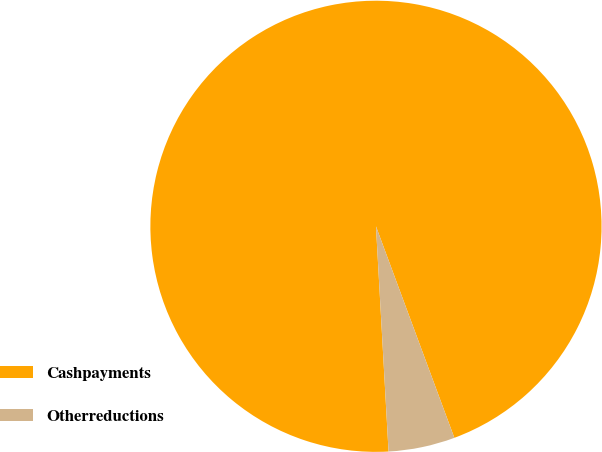Convert chart to OTSL. <chart><loc_0><loc_0><loc_500><loc_500><pie_chart><fcel>Cashpayments<fcel>Otherreductions<nl><fcel>95.24%<fcel>4.76%<nl></chart> 